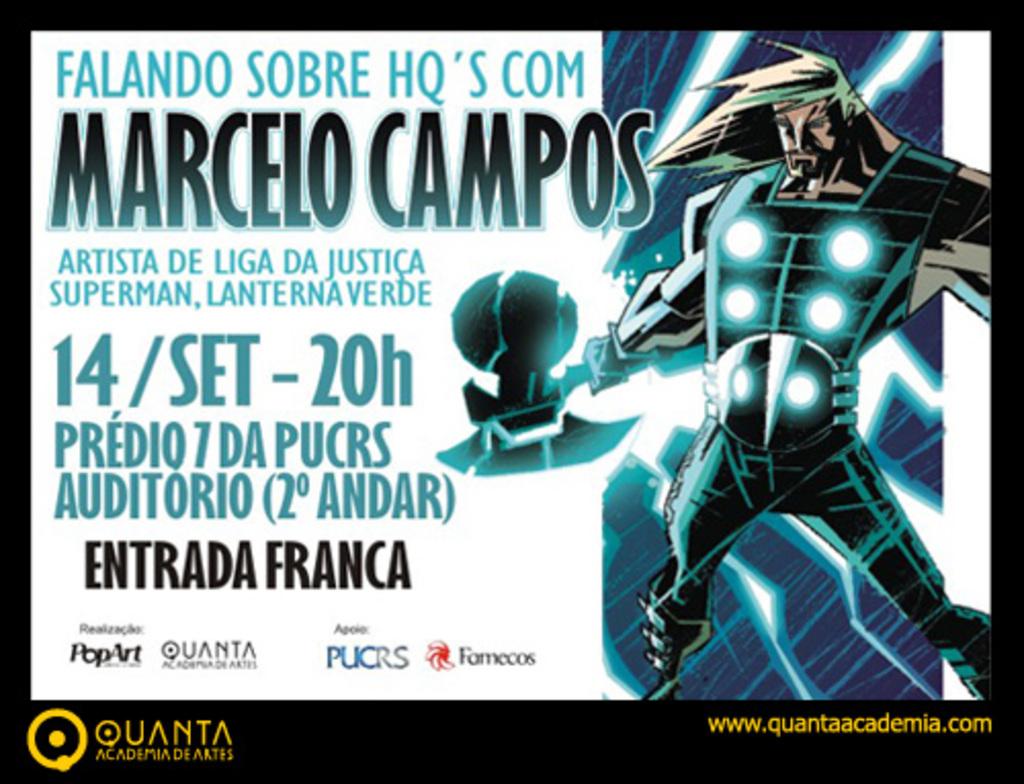What is the website you can go to find out more?
Make the answer very short. Www.quantaacademia.com. 